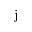<formula> <loc_0><loc_0><loc_500><loc_500>j</formula> 